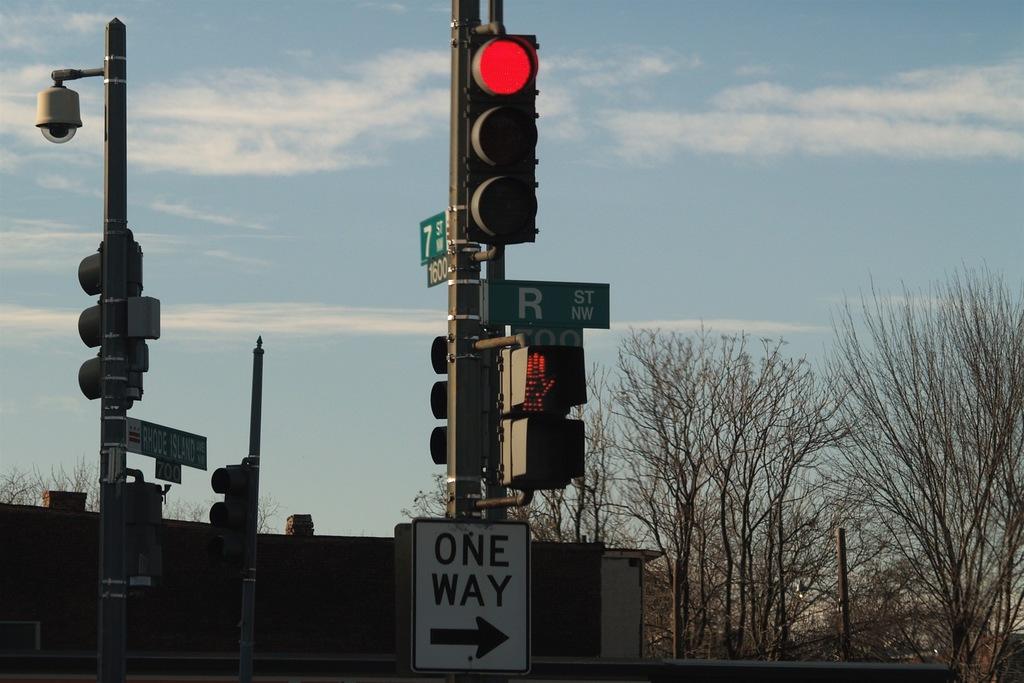Can you take a left on this street?
Offer a very short reply. No. 